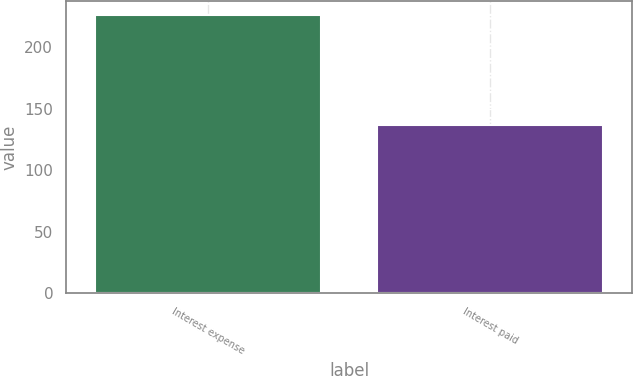Convert chart. <chart><loc_0><loc_0><loc_500><loc_500><bar_chart><fcel>Interest expense<fcel>Interest paid<nl><fcel>226<fcel>137<nl></chart> 